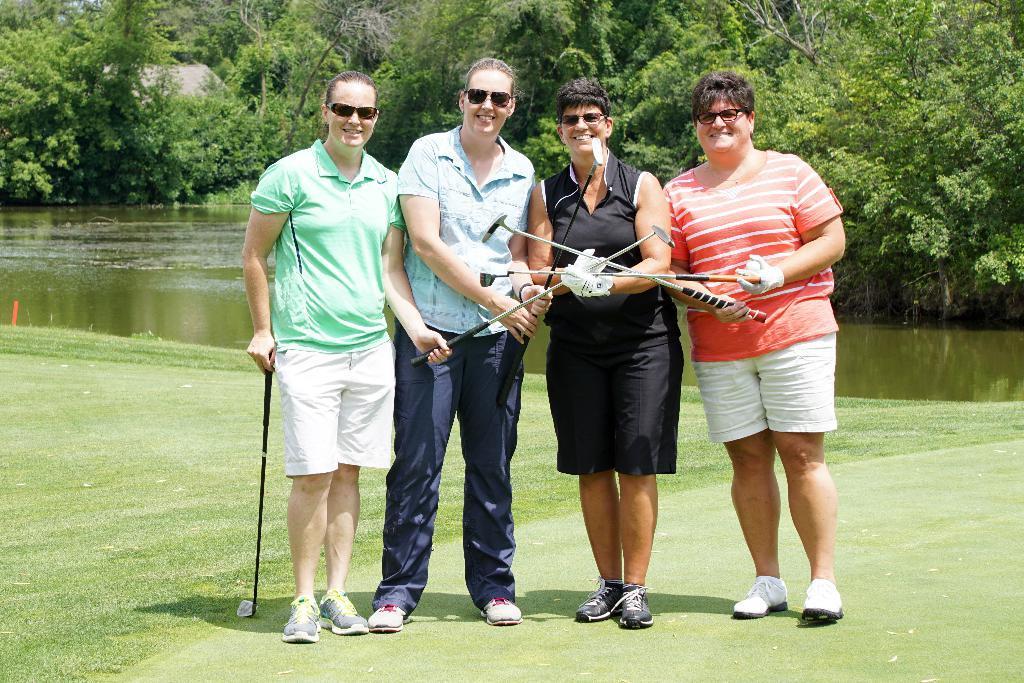Describe this image in one or two sentences. In this image I can see four women holding golf bats in the hands, standing on the ground, smiling and giving pose for the picture. In the background there is a river and many trees. 